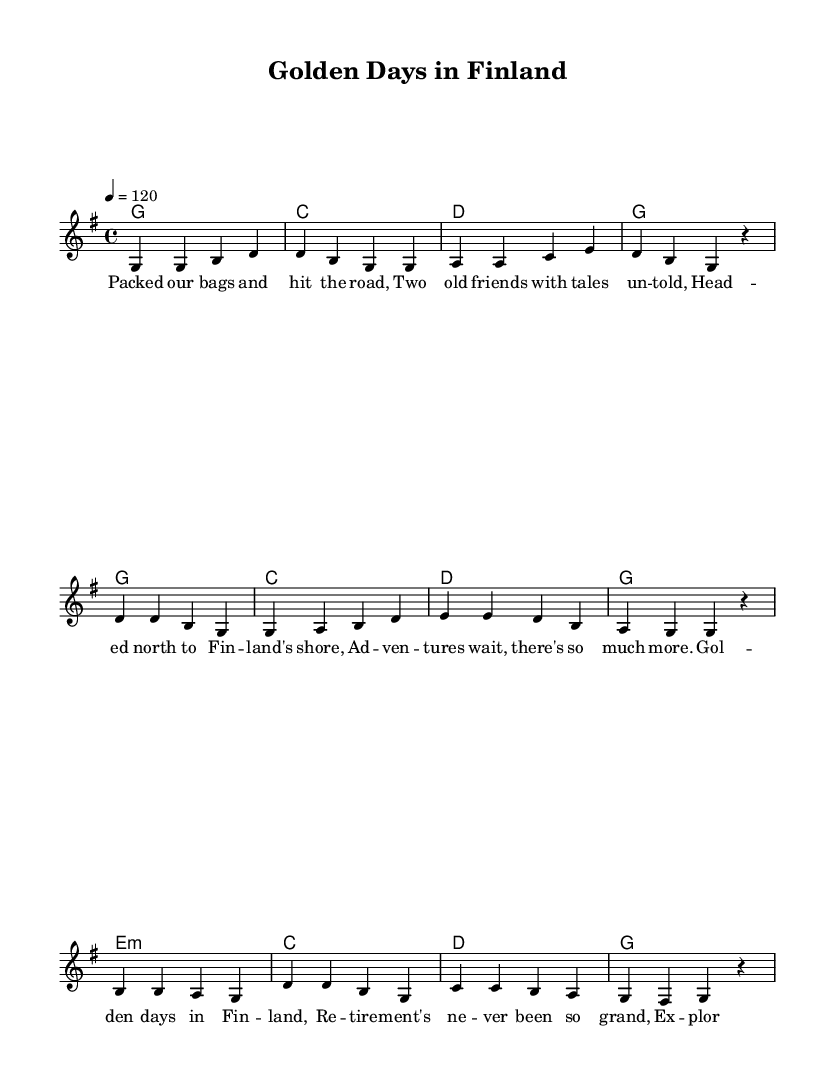What is the key signature of this music? The key signature is G major, which has one sharp (F#). It can be identified by looking for the sharp symbol and noting that it appears on the F line in the staff.
Answer: G major What is the time signature of the piece? The time signature is 4/4, which indicates there are four beats per measure, and the quarter note gets one beat. This is indicated at the beginning of the score right after the key signature.
Answer: 4/4 What is the tempo marking for this piece? The tempo marking is quarter note equals 120. This indicates that the piece should be played at a brisk speed of 120 beats per minute, and it’s specified at the beginning of the score.
Answer: 120 How many measures are in the verse section? The verse section contains 4 measures as indicated by the vertical lines separating each group of notes in that section. Counting the lines gives us the total.
Answer: 4 What is the mood conveyed in the lyrics of the chorus? The lyrics of the chorus celebrate the joy of retirement and the experiences shared with a lifelong friend. This is evident in the phrases that express happiness and cherished memories throughout the lines.
Answer: Joyful What chord follows the last measure of the bridge? The last measure of the bridge has the chord G, which can be deduced from observing that the harmonies section lists it at the end of the bridge. Chords are indicated directly below the melody notes.
Answer: G What is the primary theme of the song? The primary theme of the song revolves around friendship and exploring new adventures during retirement, as outlined in both the lyrics and the overall celebration of life and experiences shared.
Answer: Friendship and exploration 